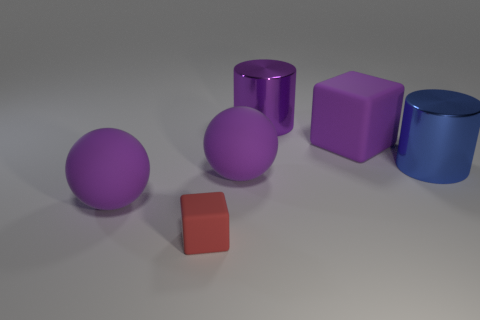Add 4 large blocks. How many objects exist? 10 Subtract all cylinders. How many objects are left? 4 Subtract 1 purple cylinders. How many objects are left? 5 Subtract all large rubber blocks. Subtract all matte balls. How many objects are left? 3 Add 5 rubber balls. How many rubber balls are left? 7 Add 6 tiny cubes. How many tiny cubes exist? 7 